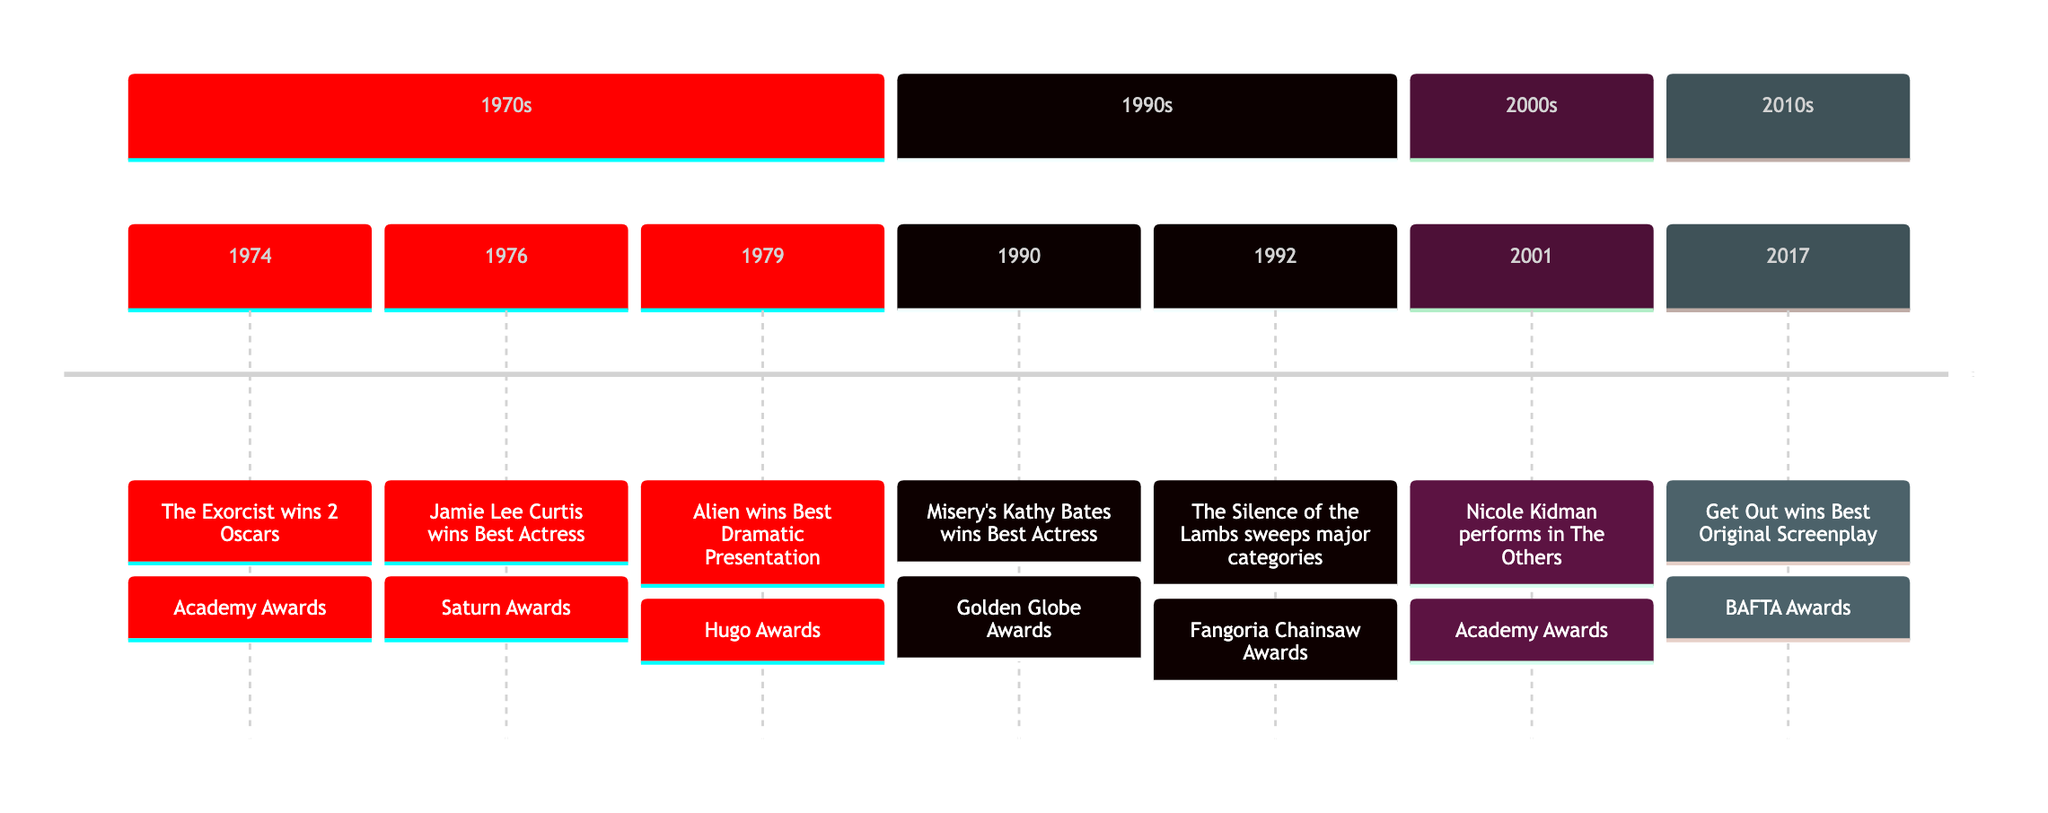What major award did "The Exorcist" win in 1974? In 1974, "The Exorcist" is noted in the timeline as winning 2 Oscars, which is a significant recognition at the Academy Awards.
Answer: 2 Oscars Who won Best Actress at the Saturn Awards in 1976? The timeline identifies Jamie Lee Curtis as the Best Actress winner at the Saturn Awards in 1976, marking her notable achievement in horror films.
Answer: Jamie Lee Curtis Which film won Best Dramatic Presentation in 1979? The timeline explicitly states that "Alien" won the award for Best Dramatic Presentation at the Hugo Awards in 1979, indicating its impact on the genre.
Answer: Alien What major awards did "The Silence of the Lambs" win in 1992? In 1992, "The Silence of the Lambs" is highlighted for sweeping major categories at the Fangoria Chainsaw Awards, showing its critical acclaim during that era.
Answer: Fangoria Chainsaw Awards Which actress won a Golden Globe for "Misery" in 1990? The diagram indicates that Kathy Bates won Best Actress at the Golden Globe Awards for her performance in "Misery" in 1990, marking a significant moment in horror films.
Answer: Kathy Bates In what year did "Get Out" win Best Original Screenplay? The timeline shows that "Get Out" won the award for Best Original Screenplay at the BAFTA Awards in 2017, emphasizing its groundbreaking contribution to the genre.
Answer: 2017 Which decade saw "Nicole Kidman performs in The Others"? The timeline categorizes this event as taking place in the 2000s, noting its significance within that decade of horror cinema.
Answer: 2000s How many distinct awards are mentioned in the timeline? By counting the separate award winners and events listed in the timeline, we can identify that there are 6 distinct awards highlighted, showcasing the variety of recognitions in horror films.
Answer: 6 